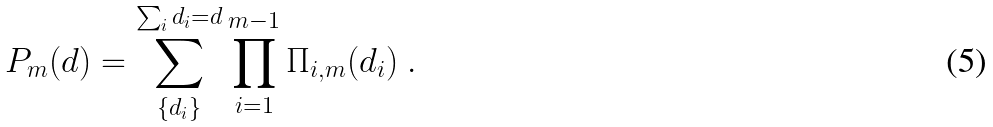<formula> <loc_0><loc_0><loc_500><loc_500>P _ { m } ( d ) = \sum _ { \{ d _ { i } \} } ^ { \sum _ { i } { d _ { i } } = d } { \prod _ { i = 1 } ^ { m - 1 } { \Pi _ { i , m } ( d _ { i } ) } } \ .</formula> 